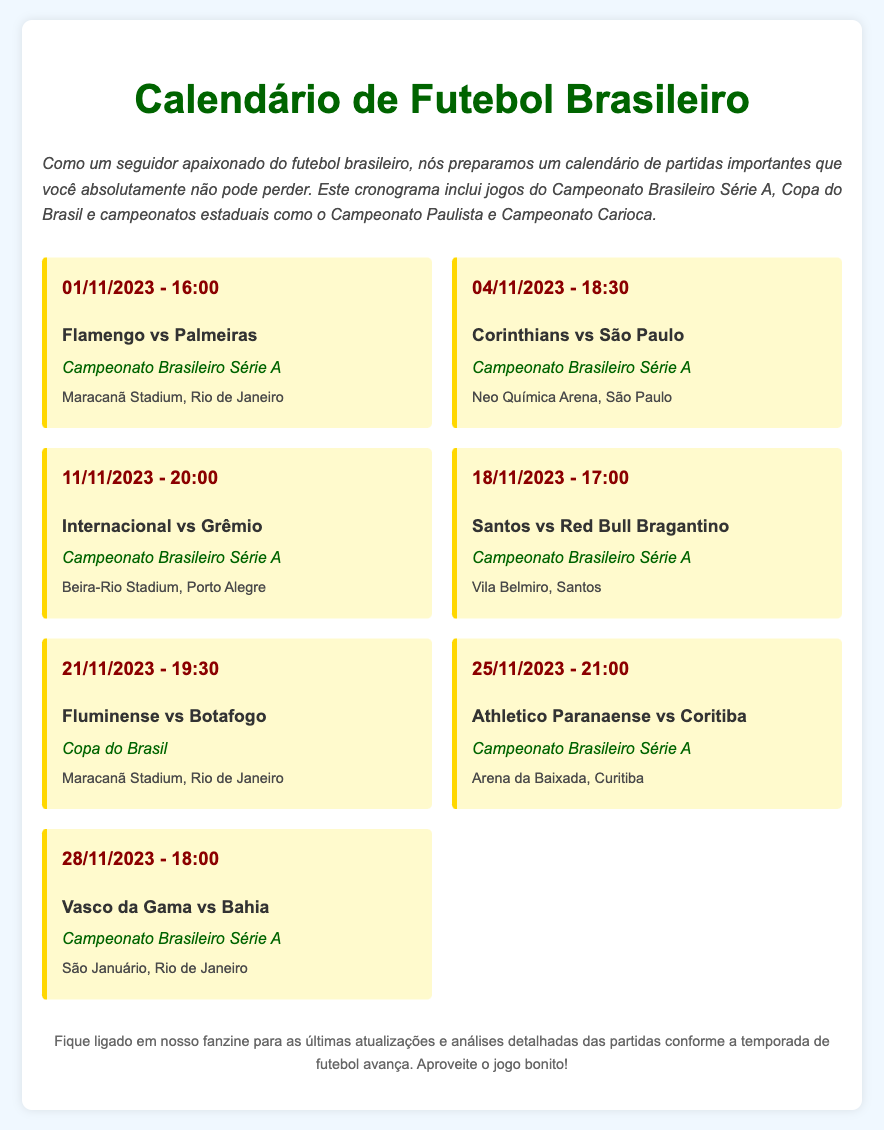what is the date of the match between Flamengo and Palmeiras? The match between Flamengo and Palmeiras is scheduled for 01/11/2023.
Answer: 01/11/2023 what time does the match between Corinthians and São Paulo start? The match starts at 18:30 on 04/11/2023.
Answer: 18:30 which competition is the match between Fluminense and Botafogo part of? The match between Fluminense and Botafogo is part of the Copa do Brasil.
Answer: Copa do Brasil where will the match between Santos and Red Bull Bragantino take place? The match will take place at Vila Belmiro, Santos.
Answer: Vila Belmiro, Santos how many matches are scheduled for November 2023? There are four matches scheduled for November 2023.
Answer: Four which teams will play at Beira-Rio Stadium? Internacional and Grêmio will play at Beira-Rio Stadium.
Answer: Internacional and Grêmio when is the match featuring Athletico Paranaense against Coritiba? The match is scheduled for 25/11/2023.
Answer: 25/11/2023 what venue will host the match between Vasco da Gama and Bahia? The match will be hosted at São Januário, Rio de Janeiro.
Answer: São Januário, Rio de Janeiro 